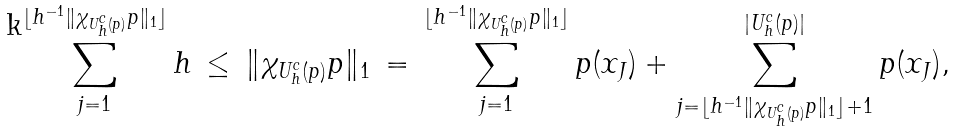<formula> <loc_0><loc_0><loc_500><loc_500>\sum _ { j = 1 } ^ { \lfloor h ^ { - 1 } \| \chi _ { U ^ { c } _ { h } ( p ) } p \| _ { 1 } \rfloor } h \, \leq \, \| \chi _ { U ^ { c } _ { h } ( p ) } p \| _ { 1 } \, = \, \sum _ { j = 1 } ^ { \lfloor h ^ { - 1 } \| \chi _ { U ^ { c } _ { h } ( p ) } p \| _ { 1 } \rfloor } p ( x _ { J } ) + \sum _ { j = \lfloor h ^ { - 1 } \| \chi _ { U ^ { c } _ { h } ( p ) } p \| _ { 1 } \rfloor + 1 } ^ { | U _ { h } ^ { c } ( p ) | } p ( x _ { J } ) ,</formula> 